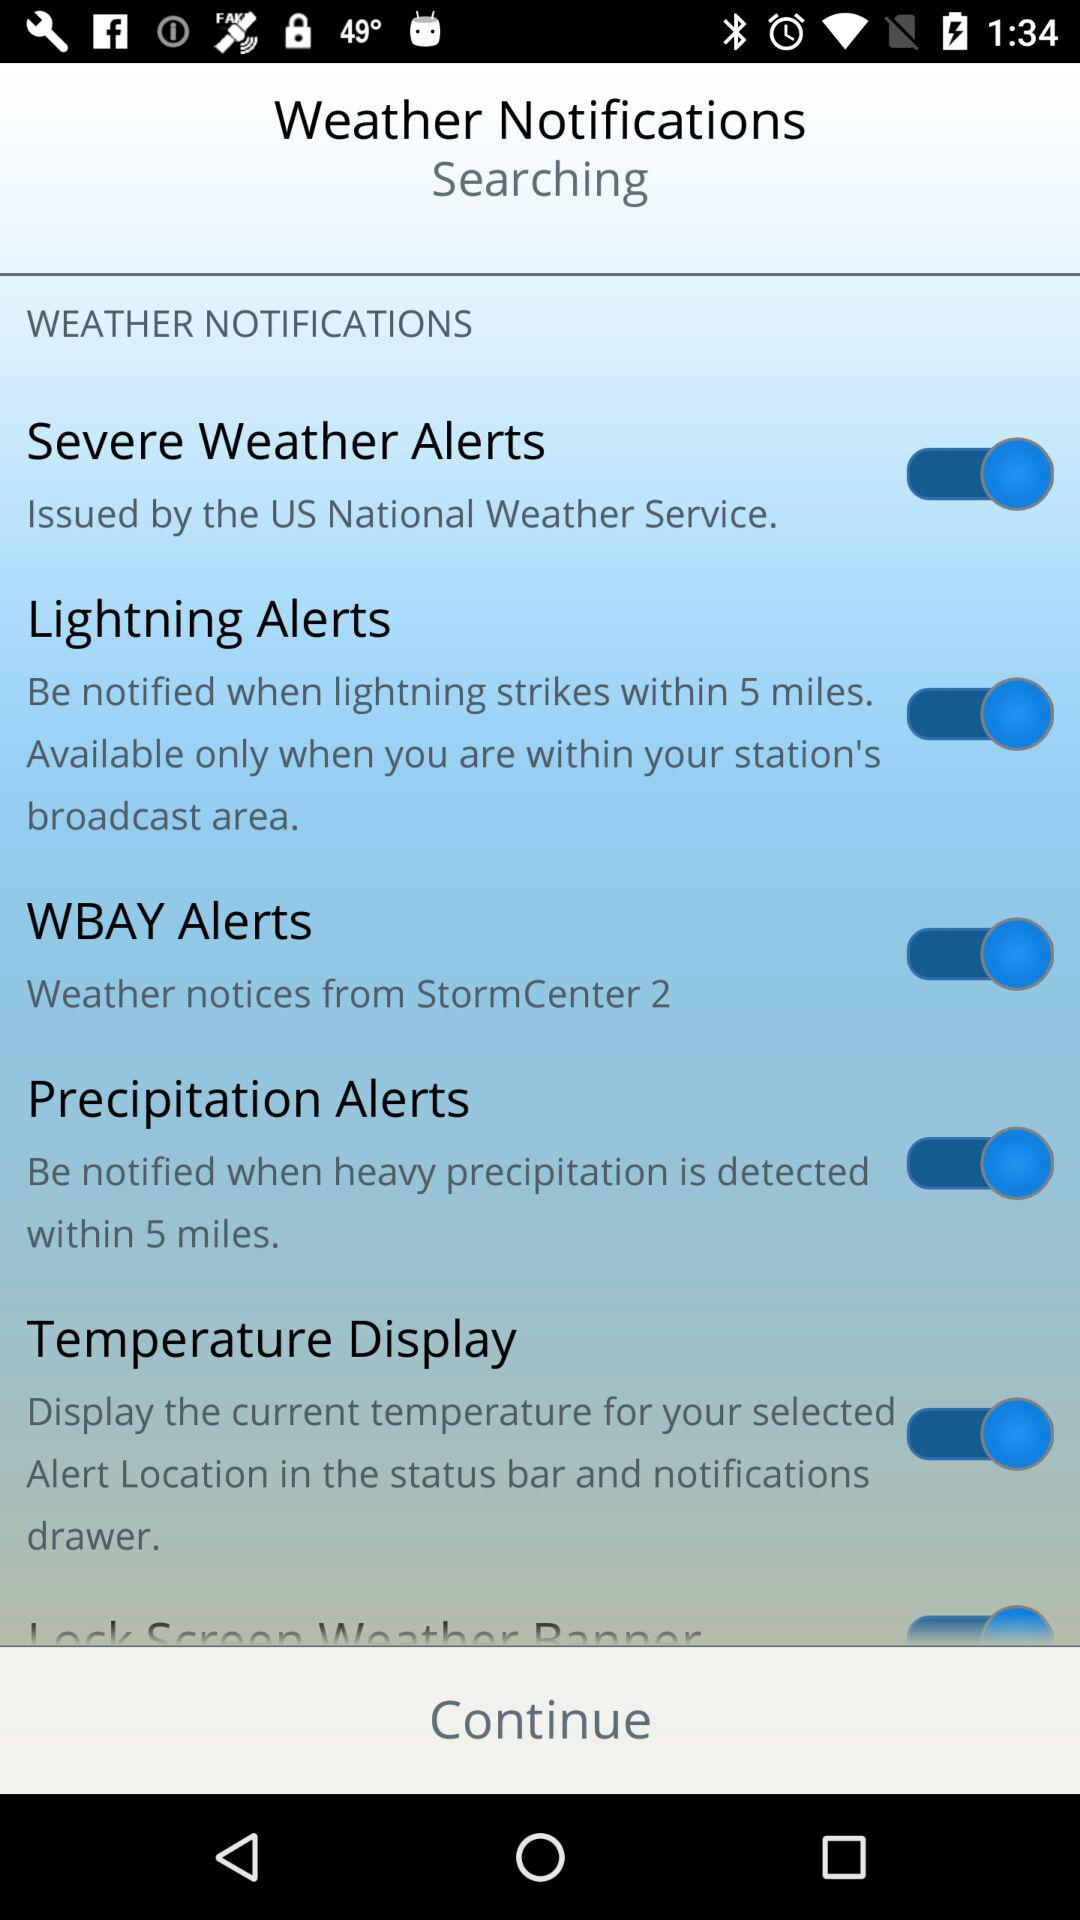What is the status of the "Lightning Alerts"? The status is "on". 